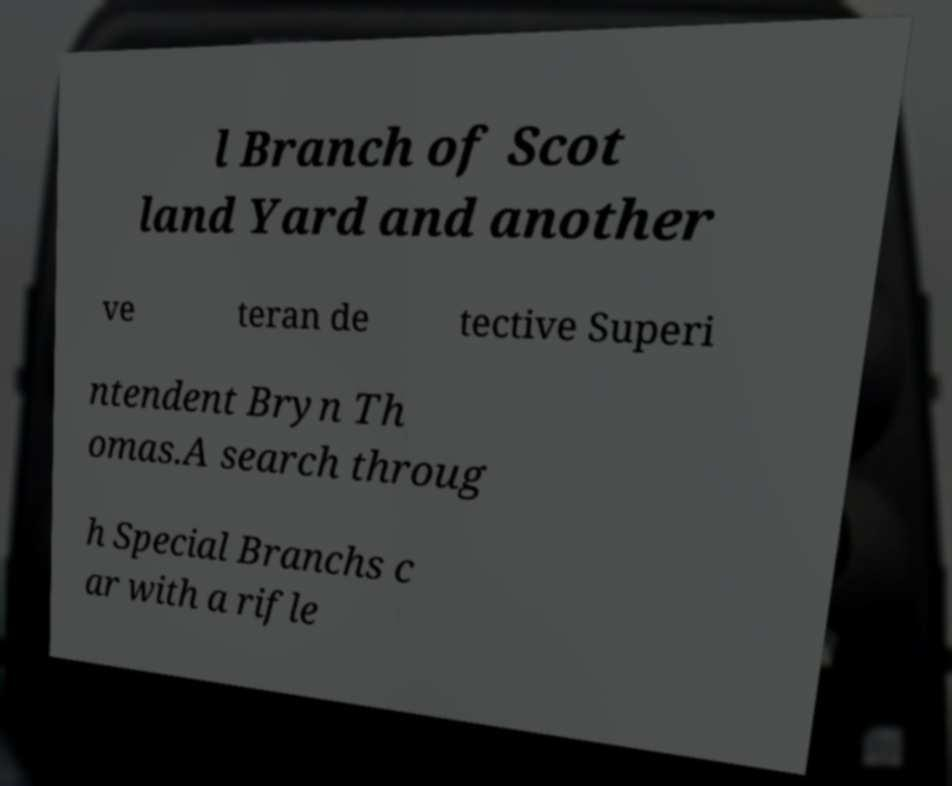Can you read and provide the text displayed in the image?This photo seems to have some interesting text. Can you extract and type it out for me? l Branch of Scot land Yard and another ve teran de tective Superi ntendent Bryn Th omas.A search throug h Special Branchs c ar with a rifle 